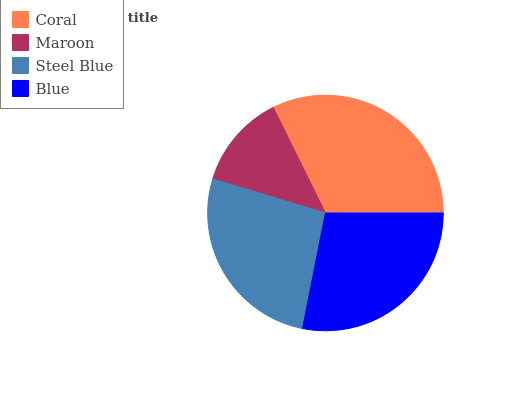Is Maroon the minimum?
Answer yes or no. Yes. Is Coral the maximum?
Answer yes or no. Yes. Is Steel Blue the minimum?
Answer yes or no. No. Is Steel Blue the maximum?
Answer yes or no. No. Is Steel Blue greater than Maroon?
Answer yes or no. Yes. Is Maroon less than Steel Blue?
Answer yes or no. Yes. Is Maroon greater than Steel Blue?
Answer yes or no. No. Is Steel Blue less than Maroon?
Answer yes or no. No. Is Blue the high median?
Answer yes or no. Yes. Is Steel Blue the low median?
Answer yes or no. Yes. Is Coral the high median?
Answer yes or no. No. Is Coral the low median?
Answer yes or no. No. 